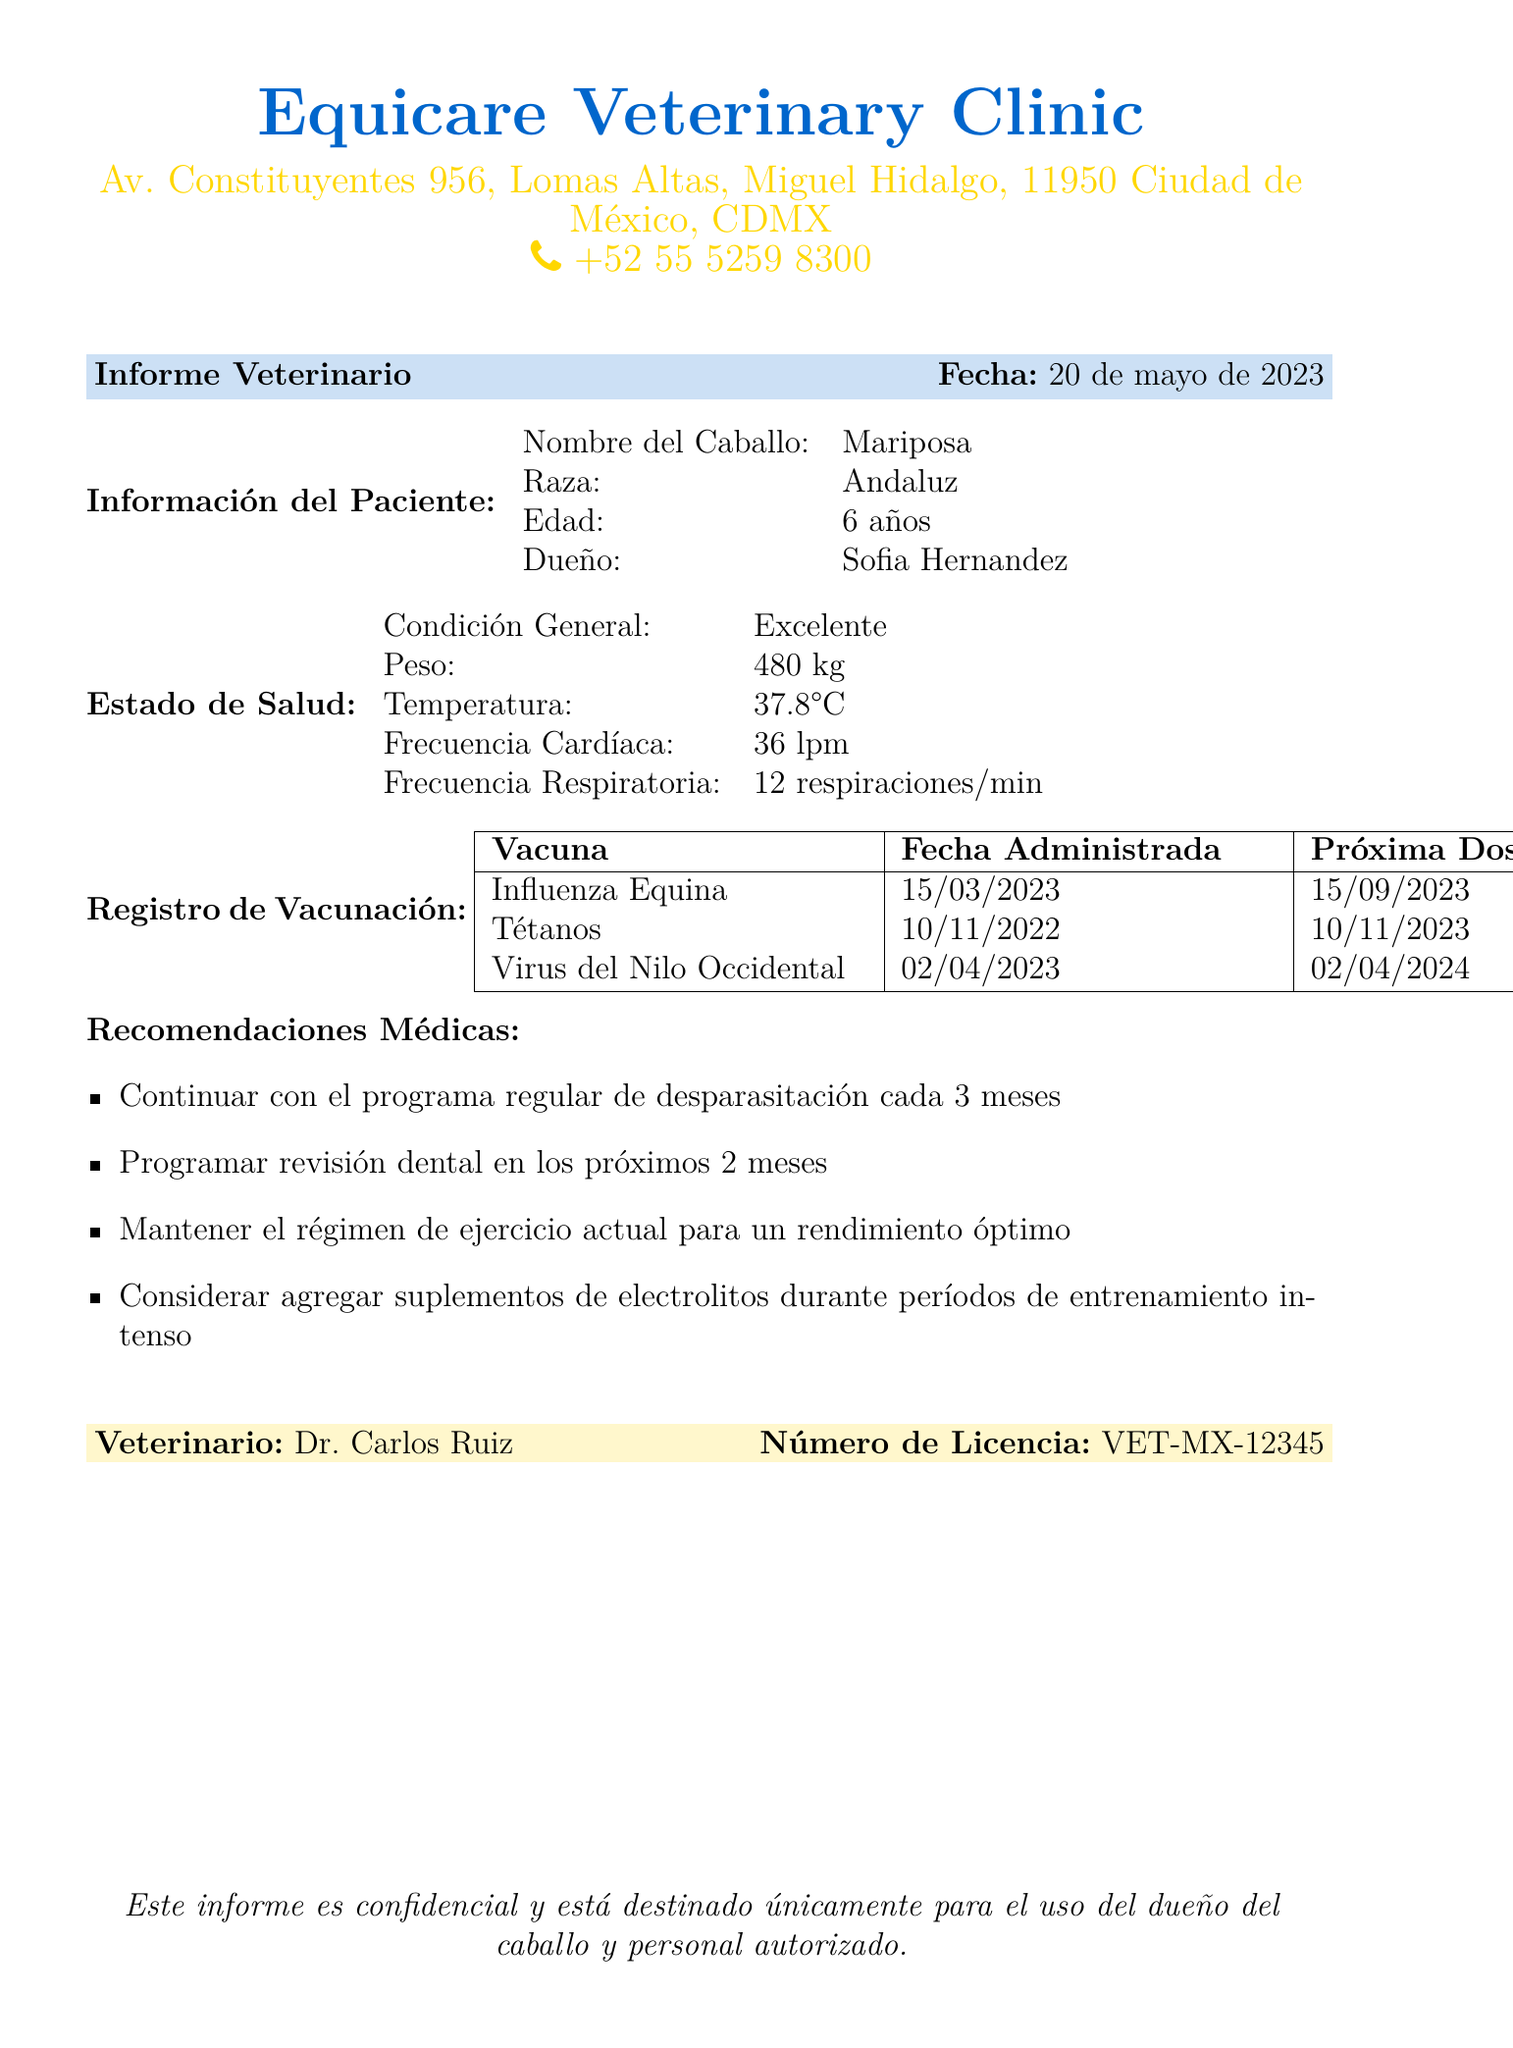¿Qué es el nombre del caballo? El nombre del caballo se encuentra en la sección de información del paciente.
Answer: Mariposa ¿Cuál es la raza del caballo? La raza del caballo también se menciona en la sección de información del paciente.
Answer: Andaluz ¿Cuál es la condición general del caballo? Esta información se encuentra en la sección del estado de salud.
Answer: Excelente ¿Cuándo se administró la vacuna de Influenza Equina? Esta información está presente en el registro de vacunación.
Answer: 15/03/2023 ¿Cuándo es la próxima dosis de Tétanos? El documento indica cuándo se debe administrar la próxima dosis.
Answer: 10/11/2023 ¿Qué se recomienda programar en los próximos dos meses? La recomendación está listada en las recomendaciones médicas.
Answer: Revisión dental ¿Cuál es el peso del caballo? El peso del caballo se muestra en la sección del estado de salud.
Answer: 480 kg ¿Quién es el veterinario? Esta información se encuentra al final del documento bajo la sección veterinario.
Answer: Dr. Carlos Ruiz ¿Cuál es la temperatura del caballo? La temperatura es un dato de salud del caballo mencionado en el informe.
Answer: 37.8°C 